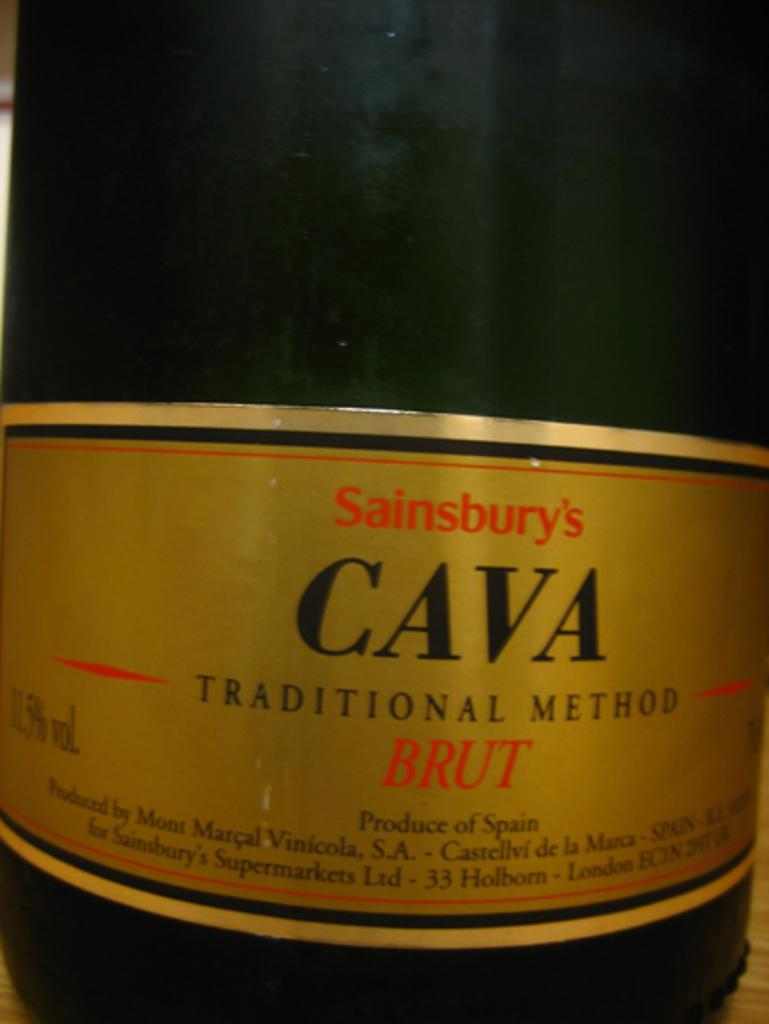<image>
Provide a brief description of the given image. the word cava that is on a bottle 